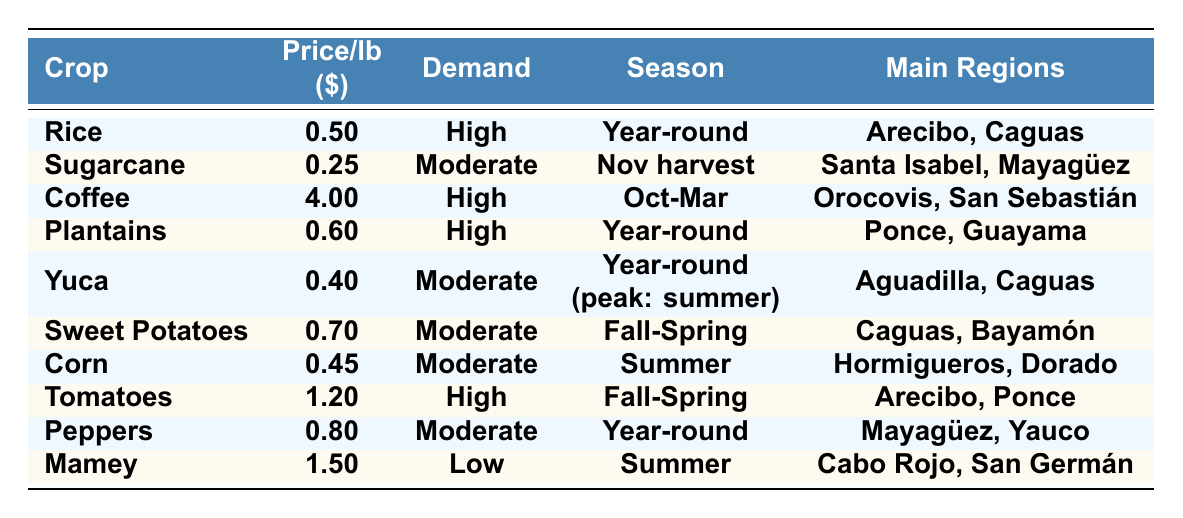What is the average price per pound of Coffee? The average price per pound for Coffee, as listed in the table, is 4.00.
Answer: 4.00 Which crop has the highest market demand? Looking at the table, Coffee, Rice, Plantains, and Tomatoes all have a high market demand, but Coffee has the highest average price among them.
Answer: Coffee, Rice, Plantains, and Tomatoes Is the average price for Sugarcane less than that of Yuca? The average price for Sugarcane is 0.25, while Yuca's average price is 0.40. Since 0.25 is less than 0.40, the statement is true.
Answer: Yes What is the seasonal harvest period for Mamey? The table states that Mamey is harvested in the Summer.
Answer: Summer If we sum the average prices of all crops, what is the total? Adding the average prices: 0.50 + 0.25 + 4.00 + 0.60 + 0.40 + 0.70 + 0.45 + 1.20 + 0.80 + 1.50 = 10.50. The total is 10.50.
Answer: 10.50 Which crop is primarily grown in Santa Isabel? The table indicates that Sugarcane is the crop primarily grown in Santa Isabel.
Answer: Sugarcane Are Plantains more expensive than Corn? The average price for Plantains is 0.60, while for Corn it is 0.45. Since 0.60 is greater than 0.45, the statement is true.
Answer: Yes What are the main regions for growing Tomatoes? According to the table, the main regions for growing Tomatoes are Arecibo and Ponce.
Answer: Arecibo, Ponce Which crop has the lowest market demand? The table shows that Mamey has the lowest market demand, labeled as "Low."
Answer: Mamey What is the difference in average price between Coffee and Sweet Potatoes? Coffee's average price is 4.00 and Sweet Potatoes' average price is 0.70. The difference is 4.00 - 0.70 = 3.30.
Answer: 3.30 How many crops are in the table with a moderate market demand? The crops with moderate market demand as indicated in the table are Sugarcane, Yuca, Sweet Potatoes, Corn, and Peppers, totaling five crops.
Answer: 5 